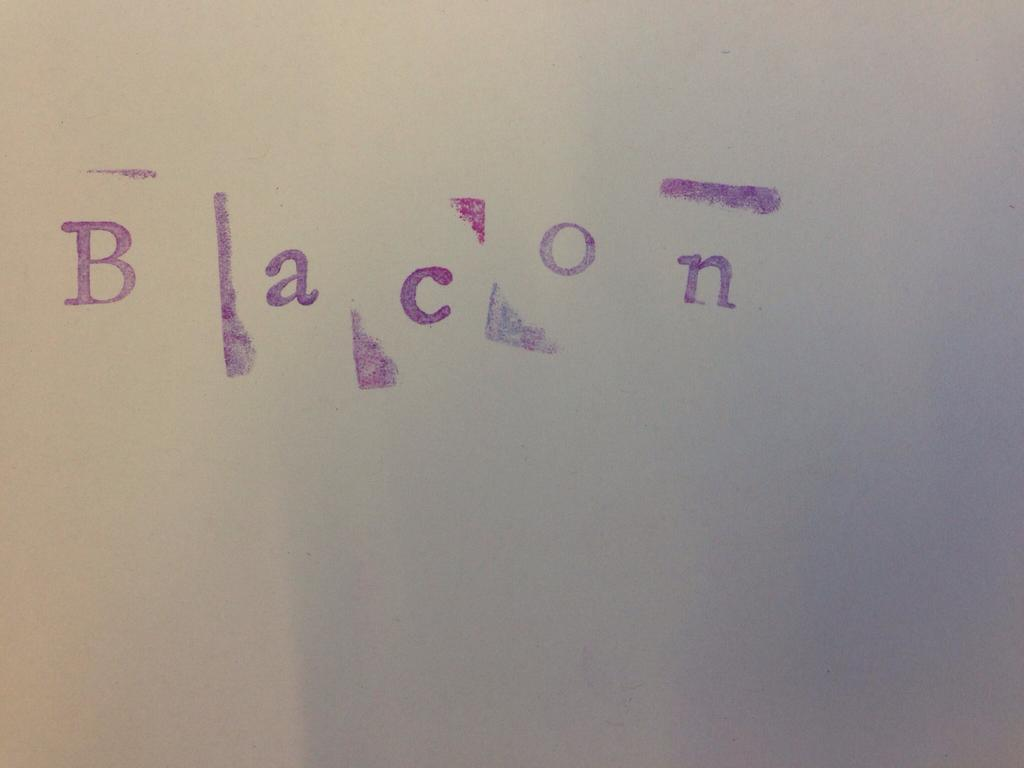<image>
Render a clear and concise summary of the photo. Someone has stamped Bacon onto a white board. 